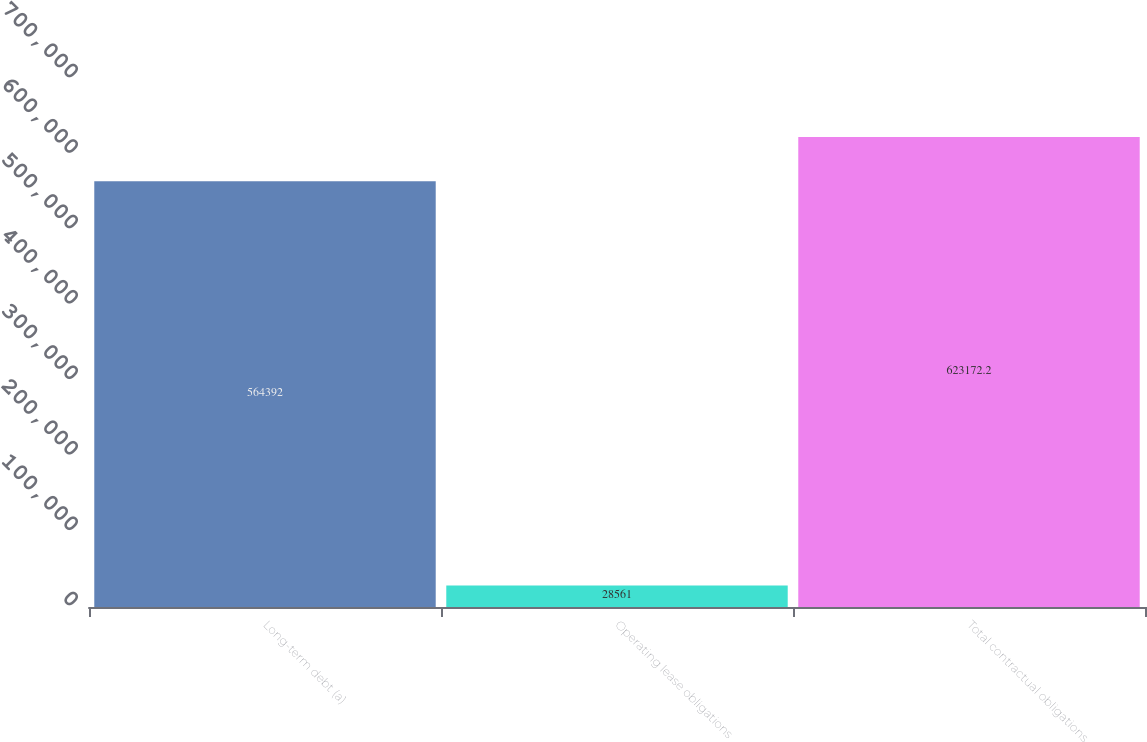Convert chart to OTSL. <chart><loc_0><loc_0><loc_500><loc_500><bar_chart><fcel>Long-term debt (a)<fcel>Operating lease obligations<fcel>Total contractual obligations<nl><fcel>564392<fcel>28561<fcel>623172<nl></chart> 